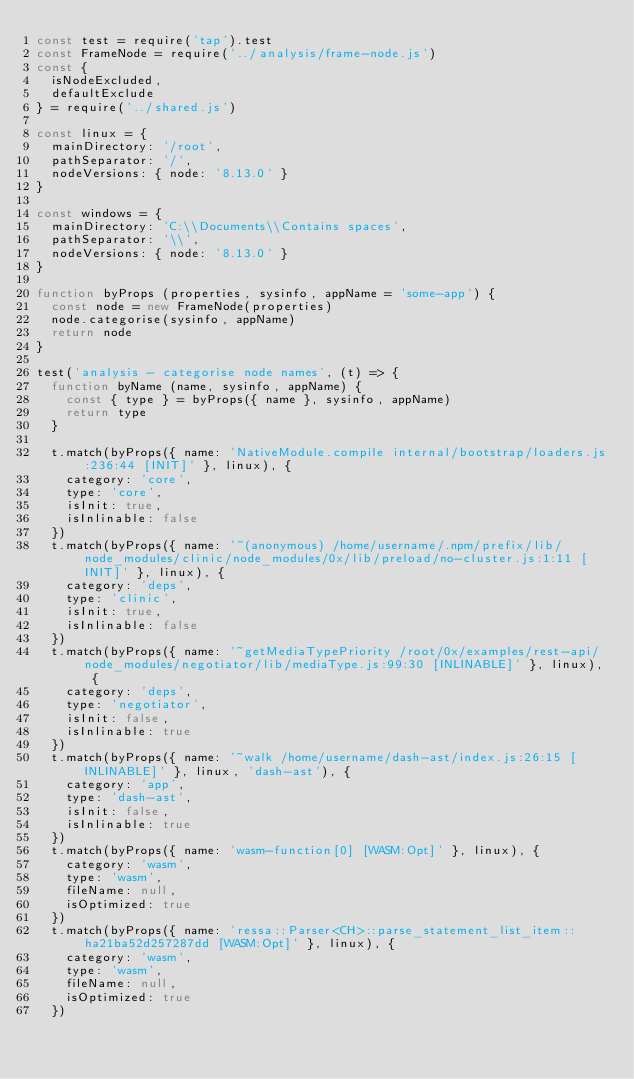Convert code to text. <code><loc_0><loc_0><loc_500><loc_500><_JavaScript_>const test = require('tap').test
const FrameNode = require('../analysis/frame-node.js')
const {
  isNodeExcluded,
  defaultExclude
} = require('../shared.js')

const linux = {
  mainDirectory: '/root',
  pathSeparator: '/',
  nodeVersions: { node: '8.13.0' }
}

const windows = {
  mainDirectory: 'C:\\Documents\\Contains spaces',
  pathSeparator: '\\',
  nodeVersions: { node: '8.13.0' }
}

function byProps (properties, sysinfo, appName = 'some-app') {
  const node = new FrameNode(properties)
  node.categorise(sysinfo, appName)
  return node
}

test('analysis - categorise node names', (t) => {
  function byName (name, sysinfo, appName) {
    const { type } = byProps({ name }, sysinfo, appName)
    return type
  }

  t.match(byProps({ name: 'NativeModule.compile internal/bootstrap/loaders.js:236:44 [INIT]' }, linux), {
    category: 'core',
    type: 'core',
    isInit: true,
    isInlinable: false
  })
  t.match(byProps({ name: '~(anonymous) /home/username/.npm/prefix/lib/node_modules/clinic/node_modules/0x/lib/preload/no-cluster.js:1:11 [INIT]' }, linux), {
    category: 'deps',
    type: 'clinic',
    isInit: true,
    isInlinable: false
  })
  t.match(byProps({ name: '~getMediaTypePriority /root/0x/examples/rest-api/node_modules/negotiator/lib/mediaType.js:99:30 [INLINABLE]' }, linux), {
    category: 'deps',
    type: 'negotiator',
    isInit: false,
    isInlinable: true
  })
  t.match(byProps({ name: '~walk /home/username/dash-ast/index.js:26:15 [INLINABLE]' }, linux, 'dash-ast'), {
    category: 'app',
    type: 'dash-ast',
    isInit: false,
    isInlinable: true
  })
  t.match(byProps({ name: 'wasm-function[0] [WASM:Opt]' }, linux), {
    category: 'wasm',
    type: 'wasm',
    fileName: null,
    isOptimized: true
  })
  t.match(byProps({ name: 'ressa::Parser<CH>::parse_statement_list_item::ha21ba52d257287dd [WASM:Opt]' }, linux), {
    category: 'wasm',
    type: 'wasm',
    fileName: null,
    isOptimized: true
  })
</code> 